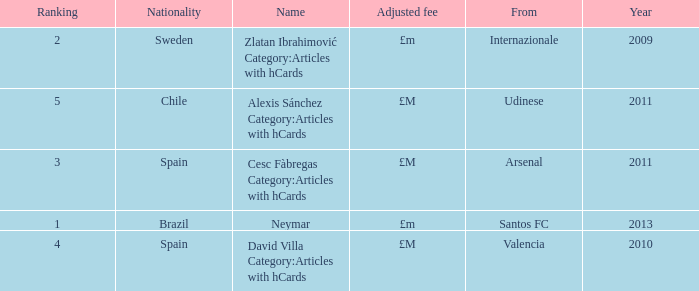What is the most recent year a player was from Valencia? 2010.0. 